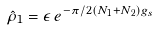Convert formula to latex. <formula><loc_0><loc_0><loc_500><loc_500>\hat { \rho } _ { 1 } = \epsilon \, e ^ { - \pi / 2 ( N _ { 1 } + N _ { 2 } ) g _ { s } }</formula> 